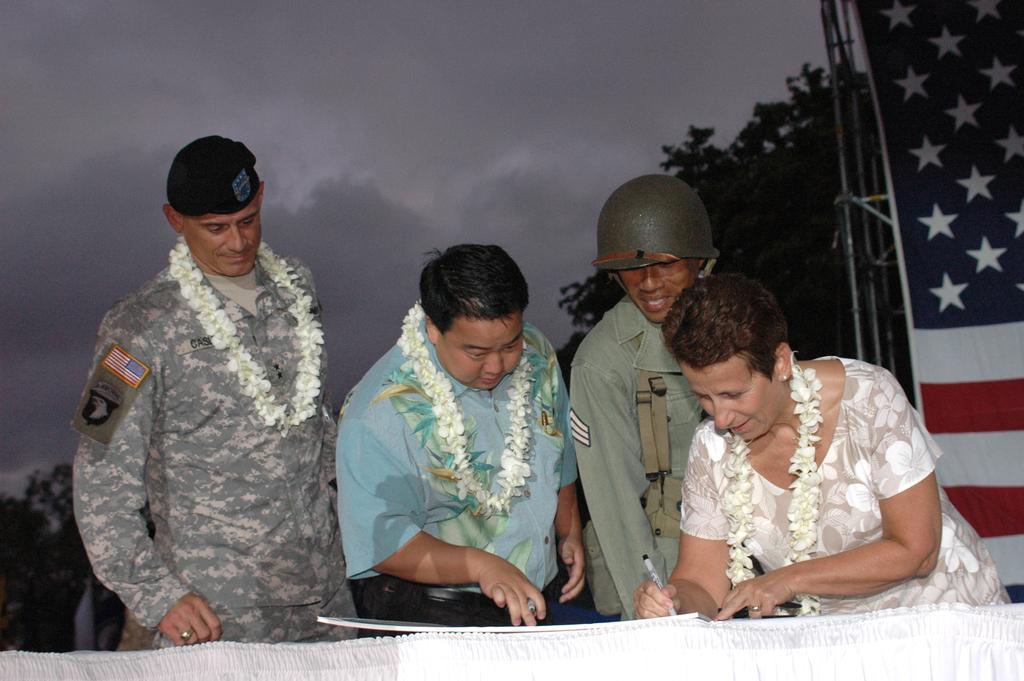Can you describe this image briefly? In the image I can see people among them three of them are wearing garlands. I can also see two of them are wearing uniforms. In the background I can see trees, the sky and some other objects. The woman on the right side is holding a pen in the hand. 